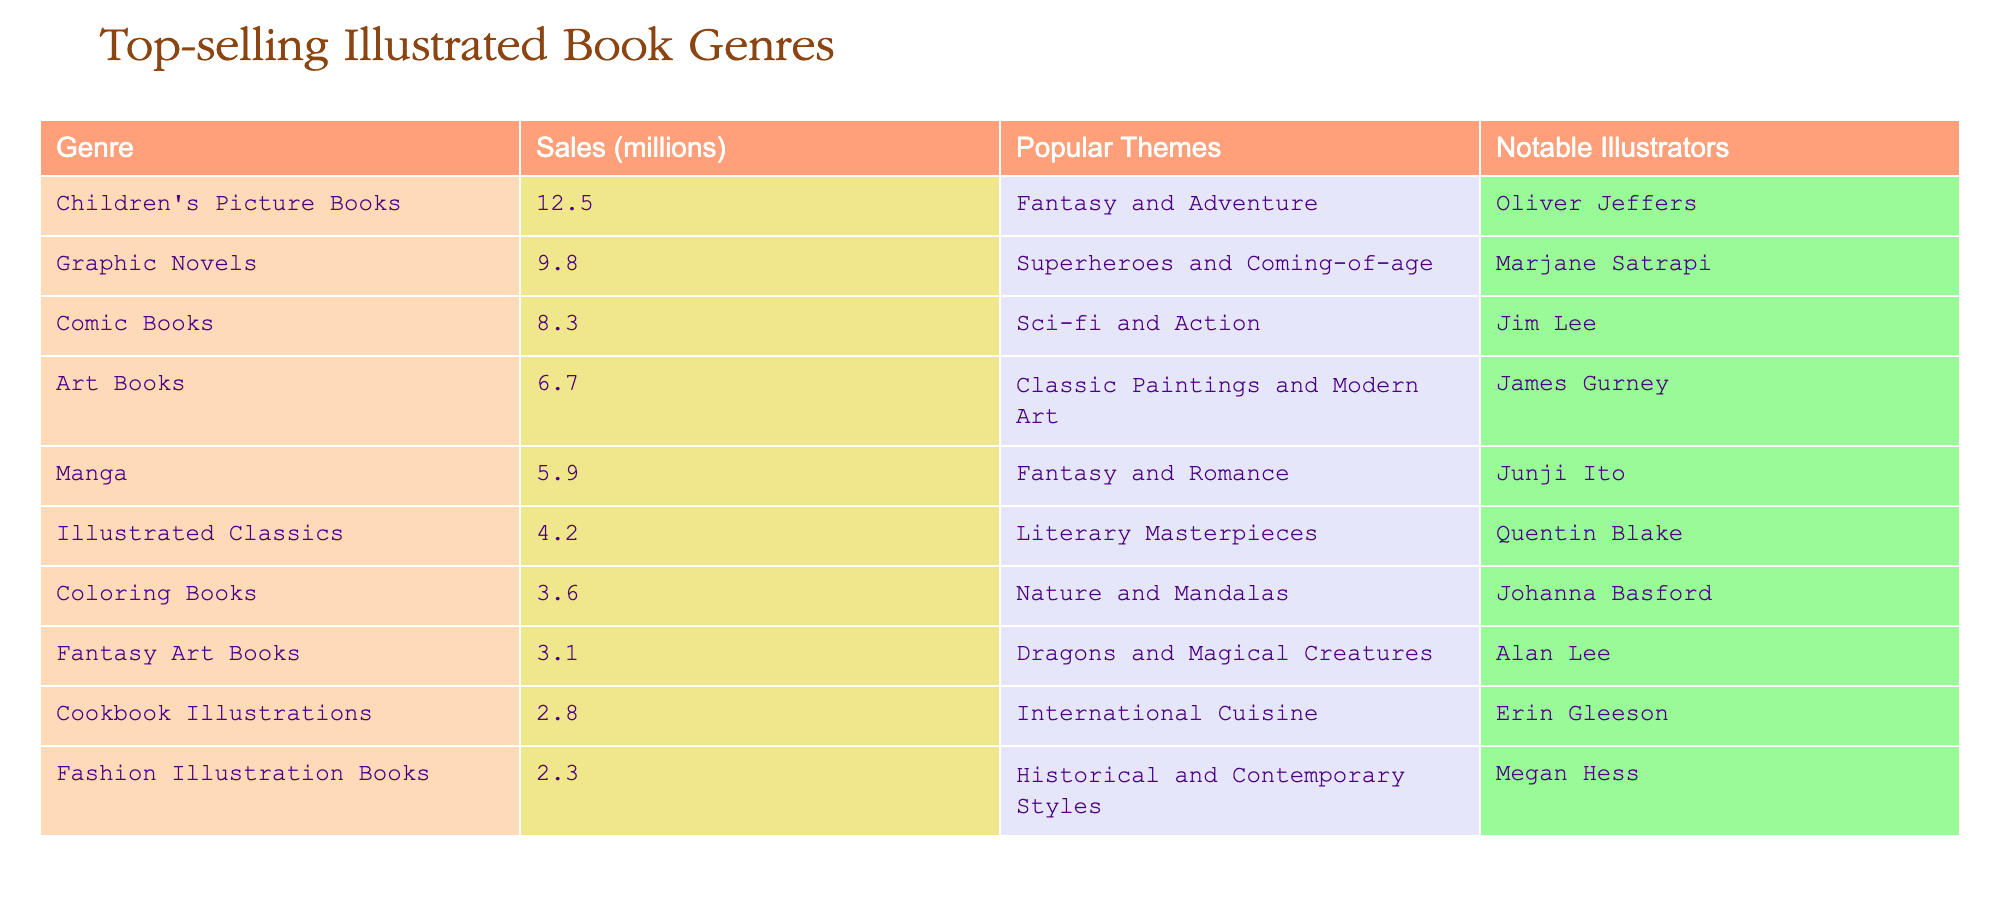What is the total sales in millions of the top-selling illustrated book genres? To find the total sales, I will add the sales of all the genres listed in the table: 12.5 + 9.8 + 8.3 + 6.7 + 5.9 + 4.2 + 3.6 + 3.1 + 2.8 + 2.3 = 59.2
Answer: 59.2 Which genre has the highest sales figure? Referring to the table, I see that the genre with the highest sales is Children's Picture Books, with 12.5 million sales.
Answer: Children's Picture Books How many genres have sales greater than 5 million? I will check the sales figures and count the genres with sales over 5 million: Children's Picture Books (12.5), Graphic Novels (9.8), Comic Books (8.3), Art Books (6.7), and Manga (5.9). That's a total of 5 genres.
Answer: 5 Is it true that the sales of Coloring Books exceed those of Cookbook Illustrations? Coloring Books have sales of 3.6 million, and Cookbook Illustrations have 2.8 million. Since 3.6 million is greater than 2.8 million, the statement is true.
Answer: Yes What theme is associated with the genre that has the least sales? The genre with the least sales is Fashion Illustration Books, which has 2.3 million sales. The theme associated with this genre is Historical and Contemporary Styles.
Answer: Historical and Contemporary Styles How much more do Children's Picture Books sell compared to Fashion Illustration Books? The sales of Children's Picture Books are 12.5 million, while Fashion Illustration Books are 2.3 million. To find the difference: 12.5 - 2.3 = 10.2 million.
Answer: 10.2 million What is the average sales figure of the genres that focus on fantasy themes? The fantasy-themed genres are Children's Picture Books (12.5), Manga (5.9), and Fantasy Art Books (3.1). The average is calculated as follows: (12.5 + 5.9 + 3.1) / 3 = 21.5 / 3 = 7.17 million.
Answer: 7.17 million Which illustrator is associated with the genre that has sales of 4.2 million? The genre with sales of 4.2 million is Illustrated Classics, and the notable illustrator associated with this genre is Quentin Blake.
Answer: Quentin Blake How many genres in the table have sales less than 4 million? Checking each genre's sales, I find that Illustrated Classics (4.2), Coloring Books (3.6), Fantasy Art Books (3.1), Cookbook Illustrations (2.8), and Fashion Illustration Books (2.3) have less than 4 million. Thus, there are 4 genres in total.
Answer: 4 